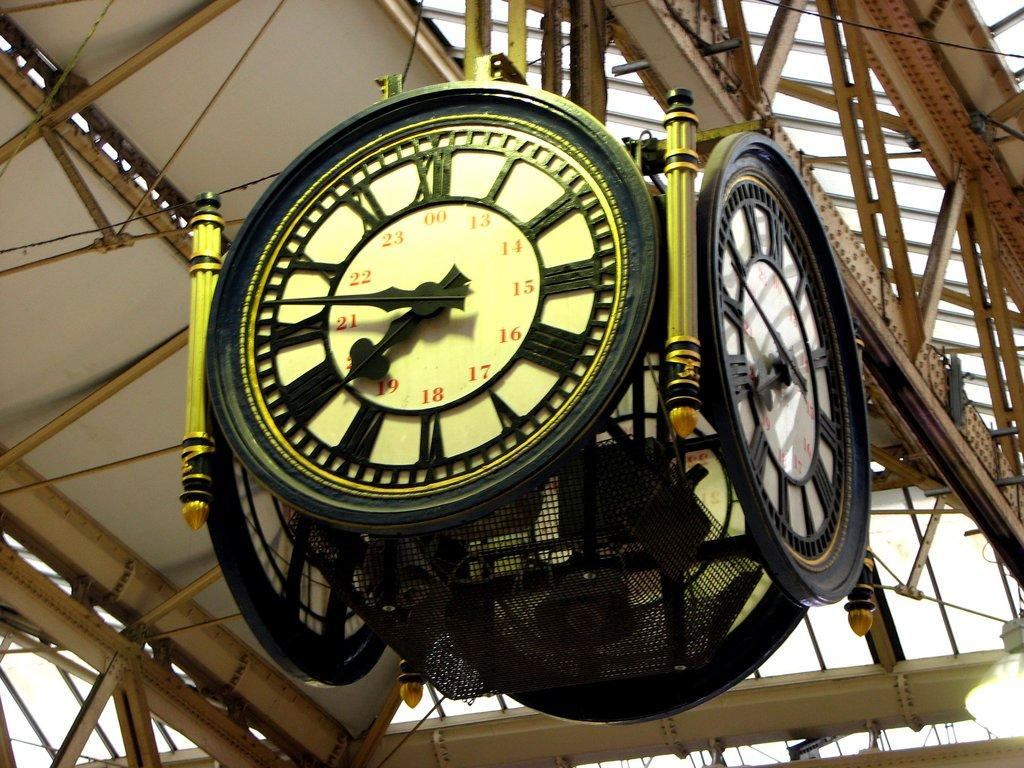<image>
Share a concise interpretation of the image provided. Hanging clock with the hands on the number 8 and 10. 